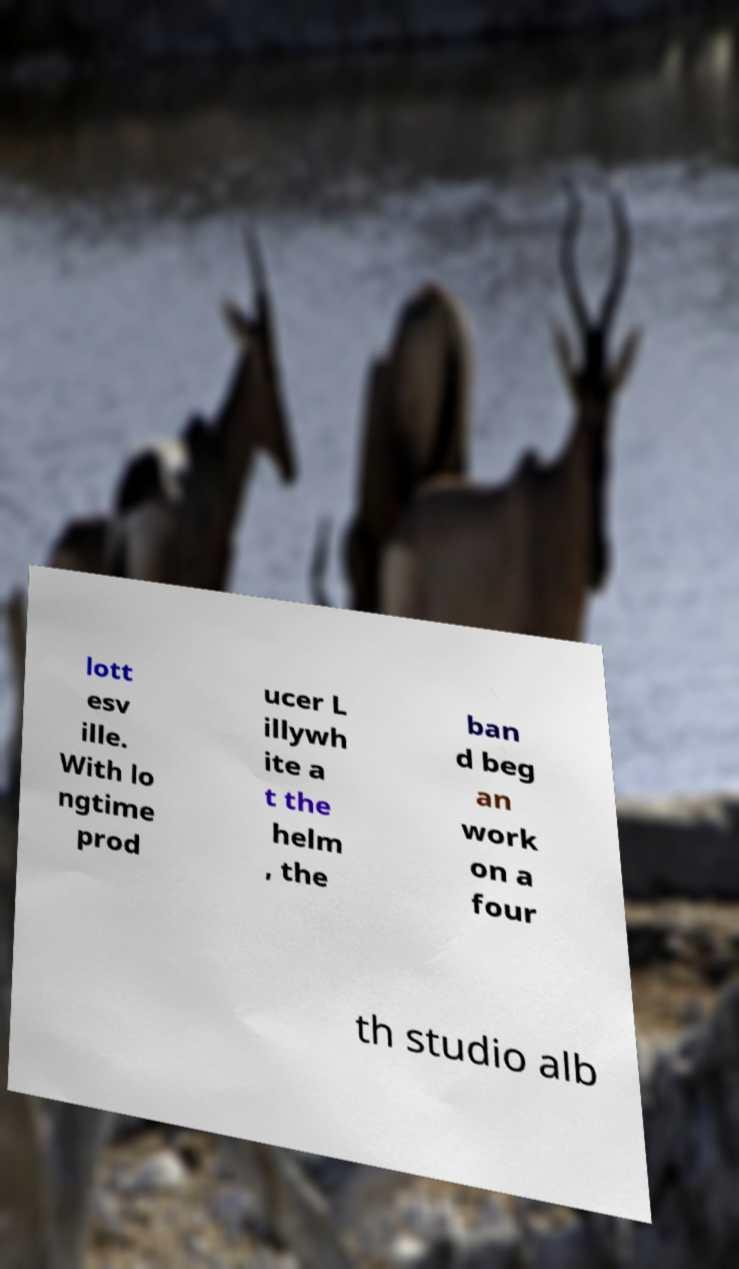Can you accurately transcribe the text from the provided image for me? lott esv ille. With lo ngtime prod ucer L illywh ite a t the helm , the ban d beg an work on a four th studio alb 